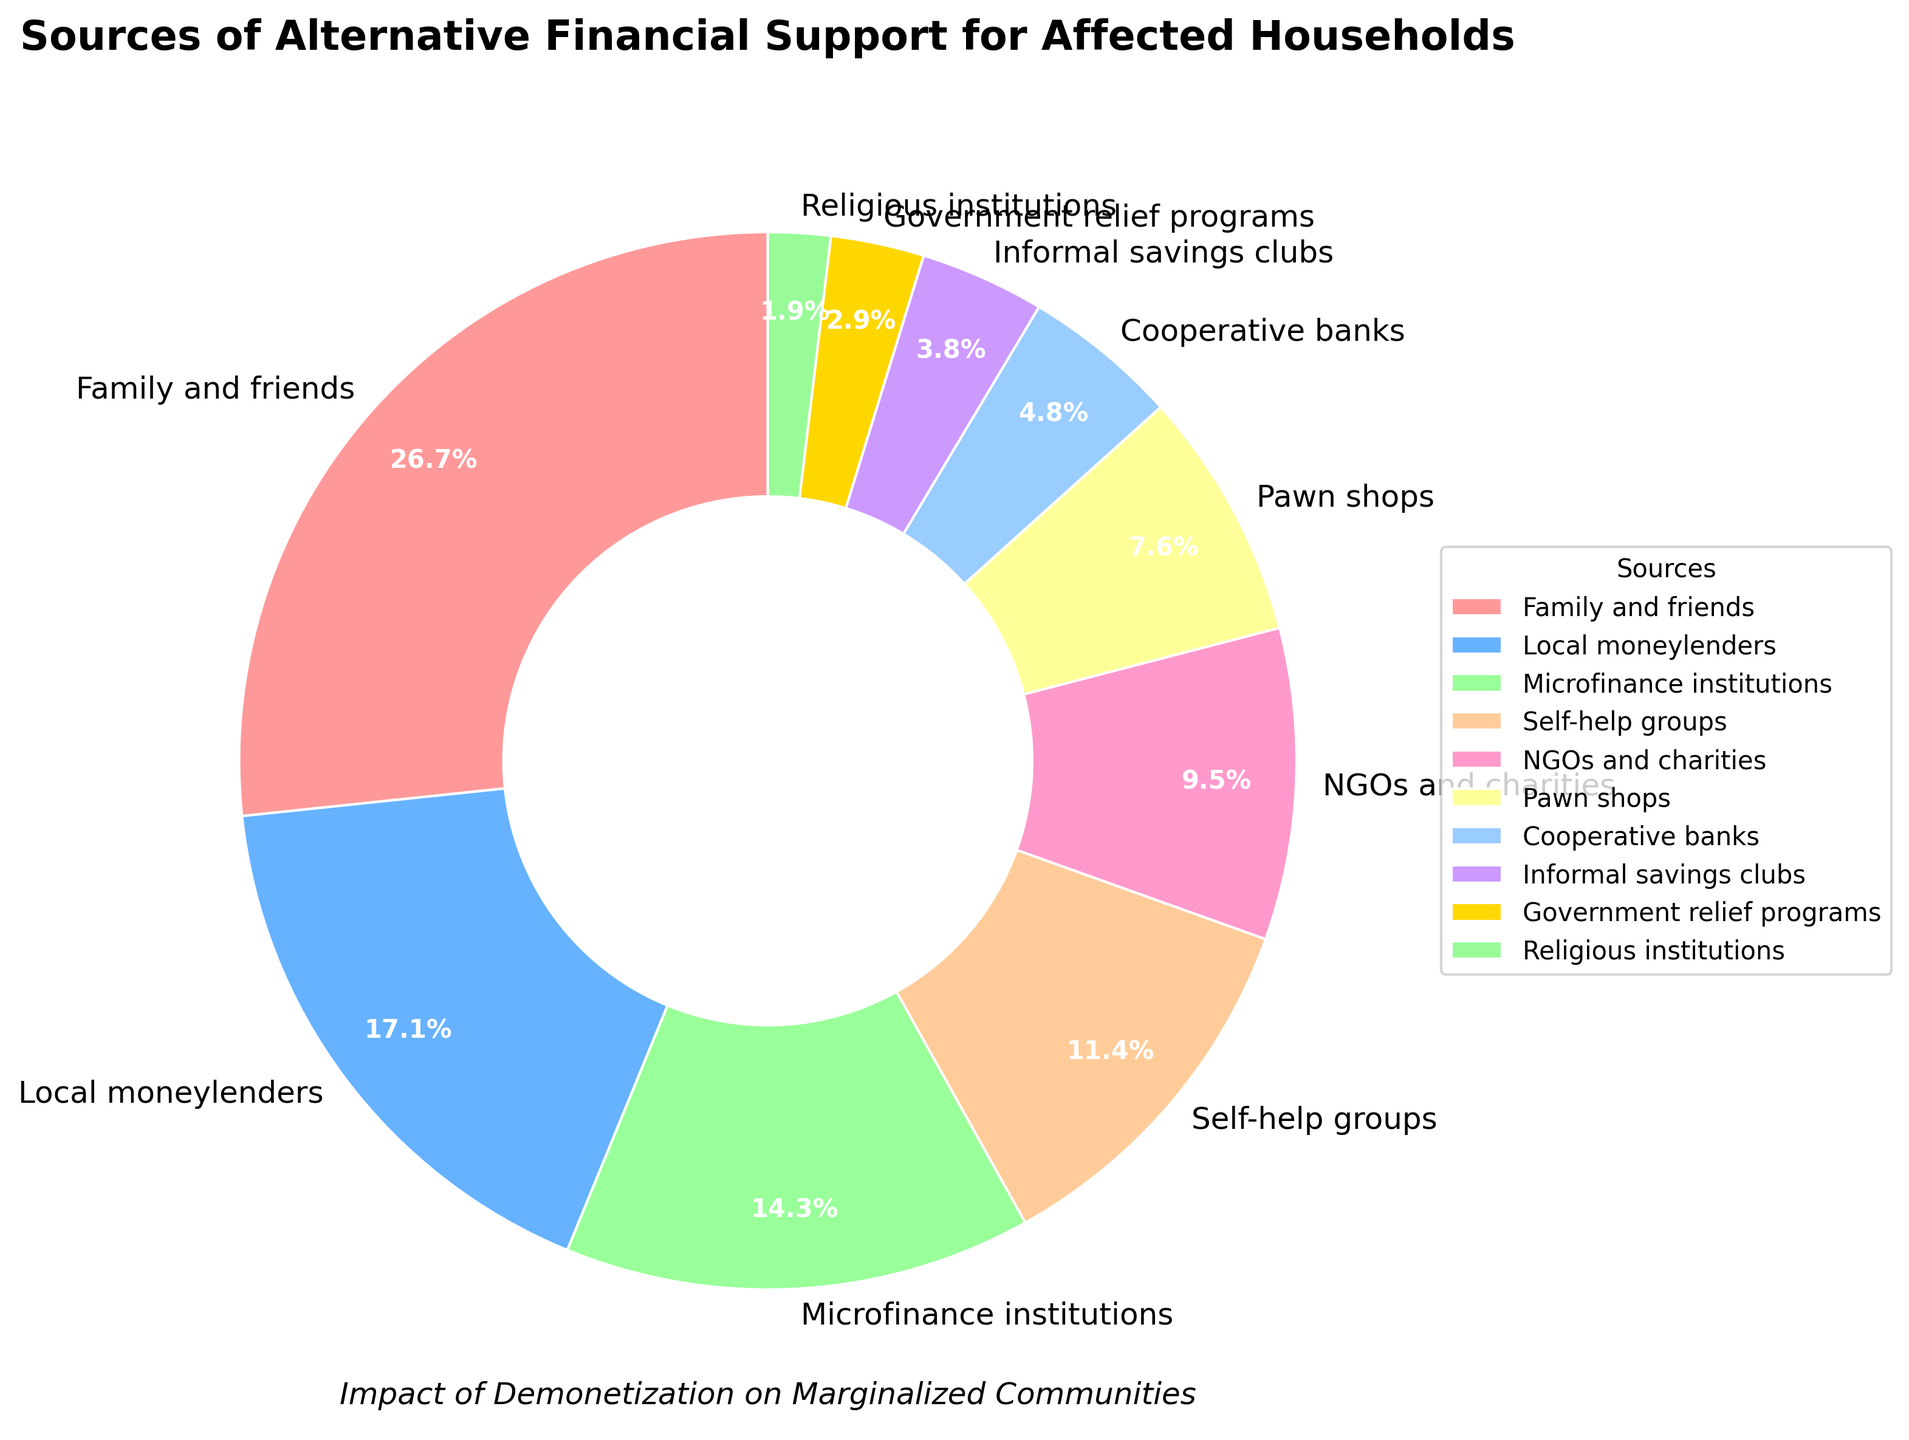Which source of financial support is the most relied upon by affected households? The segment with the largest percentage represents the most relied-upon source. 'Family and friends' is the largest segment with 28%.
Answer: Family and friends What is the combined percentage of households that rely on 'microfinance institutions' and 'self-help groups'? Add the percentages of 'microfinance institutions' (15%) and 'self-help groups' (12%). The combined percentage is 15 + 12 = 27%.
Answer: 27% Which sources provide less than 5% of the financial support? Identify the segments with percentages less than 5%. 'Cooperative banks', 'informal savings clubs', 'government relief programs', and 'religious institutions' each provide less than 5%.
Answer: 'Cooperative banks', 'informal savings clubs', 'government relief programs', 'religious institutions' How does the percentage of support from 'NGOs and charities' compare to 'Pawn shops'? Compare the percentages directly: 'NGOs and charities' provide 10% while 'Pawn shops' provide 8%, so 'NGOs and charities' is greater by 2%.
Answer: NGOs and charities have 2% more What percentage of support do 'local moneylenders' provide, and what is its rank among all categories? Identify the percentage for 'local moneylenders' (18%) and rank it within all percentages. It is the second highest.
Answer: 18%, second Which source provides the least financial support? Identify the segment with the smallest percentage. 'Religious institutions' provides the least support at 2%.
Answer: Religious institutions What is the total percentage of households that rely on non-institutional sources like 'family and friends', 'local moneylenders', and 'pawn shops'? Add the percentages of 'family and friends' (28%), 'local moneylenders' (18%), and 'pawn shops' (8%). The total is 28 + 18 + 8 = 54%.
Answer: 54% How much more support do 'family and friends' provide compared to 'microfinance institutions'? Calculate the difference in percentages between 'family and friends' (28%) and 'microfinance institutions' (15%). The difference is 28 - 15 = 13%.
Answer: 13% Are there more sources providing less than or equal to 10% support or more than 10%? Count the sources where the percentage is less than or equal to 10% and compare with the count of sources more than 10%. There are 6 sources ≤10% and 4 sources >10%.
Answer: More sources ≤10% 